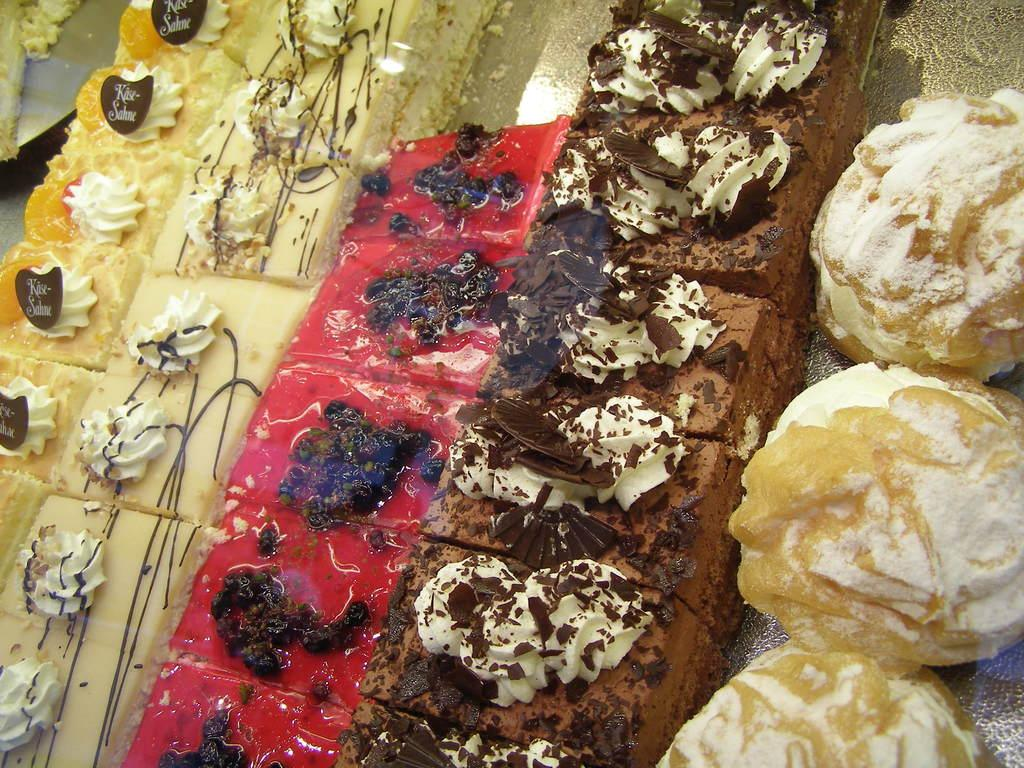What types of food can be seen in the image? There are different types of pastries and ice cream in the image. Can you describe the pastries in the image? The image shows various pastries, but specific details about their appearance or flavors are not provided. How is the ice cream presented in the image? The image only shows that there is ice cream, but it does not provide details about its presentation, such as whether it is in a bowl, cone, or another container. What type of light bulb is used to illuminate the pastries in the image? There is no information about lighting or light bulbs in the image; the focus is on the pastries and ice cream. 